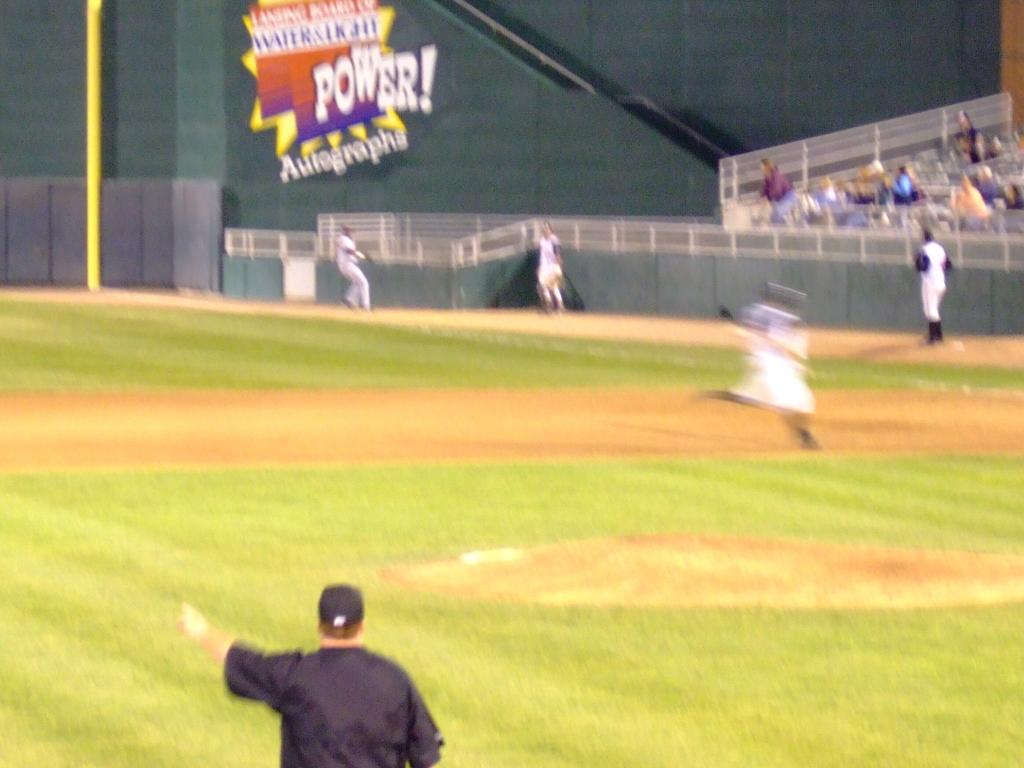<image>
Summarize the visual content of the image. A large sign reads Power! over a ballfield. 